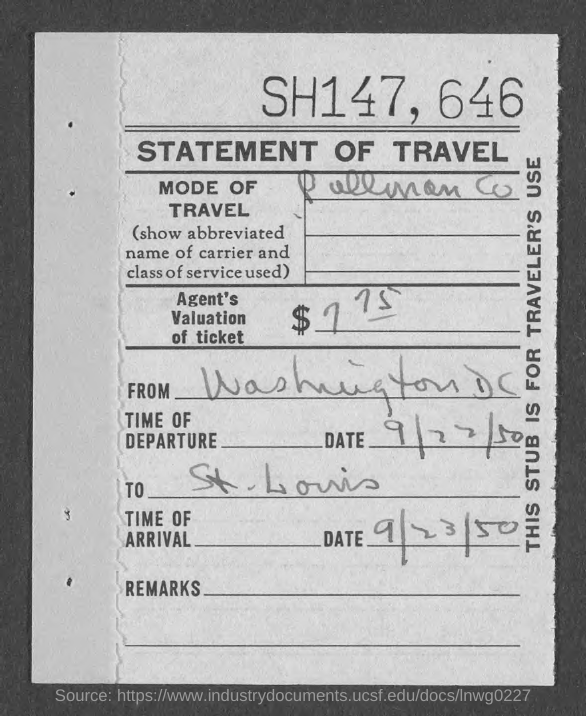Which is the date of arrival?
Provide a short and direct response. 9/23/50. 